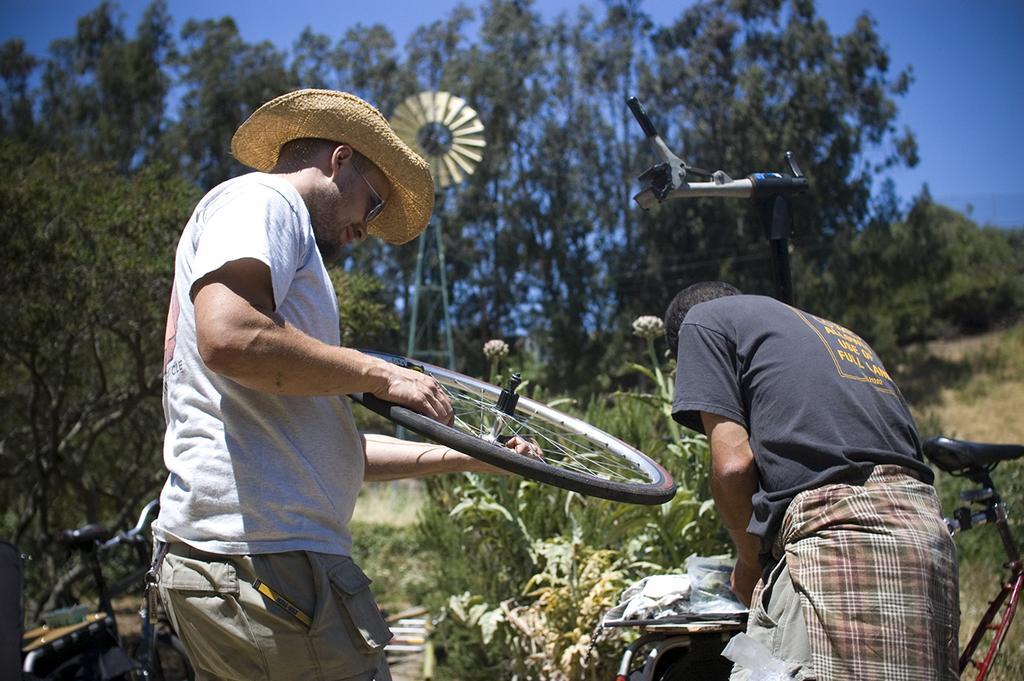How would you summarize this image in a sentence or two? This picture shows trees and we see couple of bicycles and a man holding a bicycle wheel in his hands and he wore a hat on his head and sunglasses on his face and we see another man on the side and we see a blue sky. 